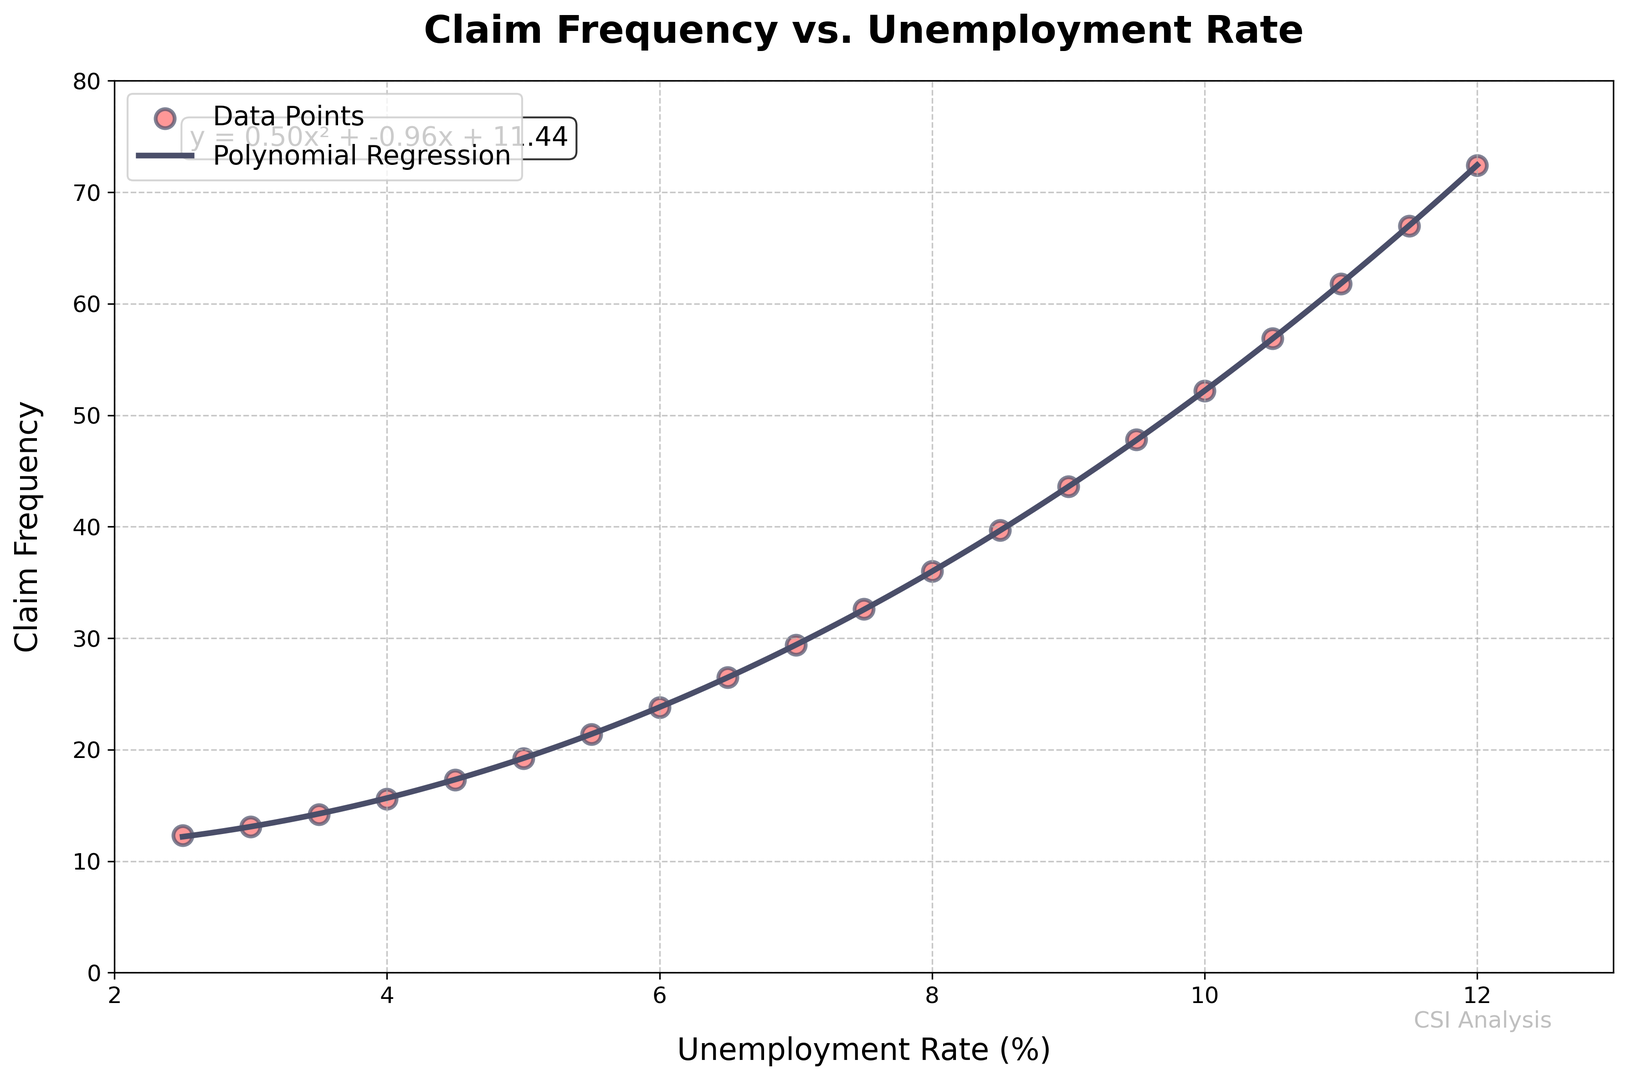What's the polynomial equation shown in the plot? The polynomial equation is displayed in a text box within the plot. It represents the fitted polynomial regression line.
Answer: y = 0.46x² + 1.97x + 9.87 What is the claim frequency when the unemployment rate is 4.5%? Identify the corresponding value on the y-axis for the unemployment rate at 4.5%. The plot shows that the claim frequency is at 17.3.
Answer: 17.3 At what unemployment rate does the fitted polynomial regression line first cross a claim frequency of 20? Locate the point on the polynomial regression line where the y-value is 20. By observing the curve, it seems to first cross this value around an unemployment rate of slightly below 5.0%.
Answer: Just below 5.0% Which unemployment rate has the highest claim frequency in the dataset? Check the data points to identify the highest y-value (claim frequency). The highest frequency occurs at an unemployment rate of 12.0%.
Answer: 12.0% What is the visual color of the data points in the scatter plot? The data points are colored in light red. This can be observed from the color of the dots in the scatter plot.
Answer: Light red How does the claim frequency change from an unemployment rate of 5.0% to 6.0%? Observe the y-values corresponding to the unemployment rates for 5.0% and 6.0%. At 5.0%, the claim frequency is 19.2, and at 6.0%, it is 23.8. The change is 23.8 - 19.2 = 4.6.
Answer: Increases by 4.6 Is the claim frequency at an unemployment rate of 9.0% greater or lesser than at 8.0%? Compare the y-values for unemployment rates of 9.0% and 8.0%. At 9.0%, the frequency is 43.6, and at 8.0%, it is 36.0. Since 43.6 is greater than 36.0, the claim frequency is greater at 9.0%.
Answer: Greater If the unemployment rate increases from 7.0% to 7.5%, what is the difference in claim frequencies? Determine the y-values for these unemployment rates: at 7.0%, the frequency is 29.4, and at 7.5%, it is 32.6. The difference is 32.6 - 29.4 = 3.2.
Answer: 3.2 What does the shading around the polynomial line indicate? There is no shading around the polynomial regression line. The line is solid and directly plotted on the scatter points.
Answer: No shading Which section of the graph shows the steepest increase in claim frequency? Examine the slope of the polynomial regression line. The section between 10.0% and 12.0% shows the steepest increase as the claim frequency rises sharply.
Answer: Between 10.0% and 12.0% 